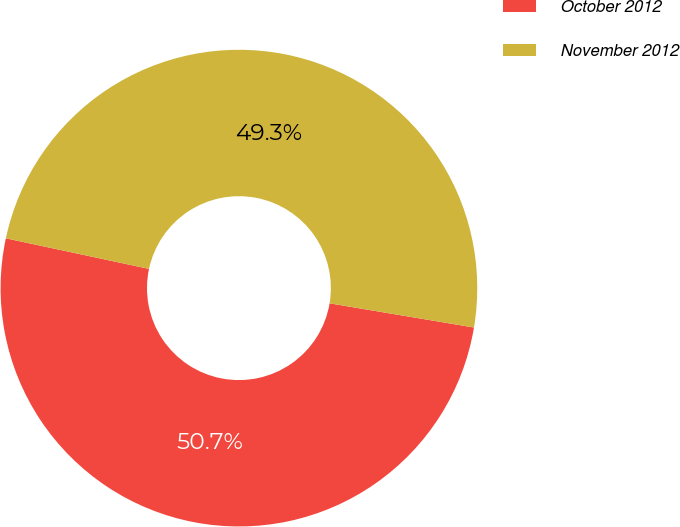Convert chart. <chart><loc_0><loc_0><loc_500><loc_500><pie_chart><fcel>October 2012<fcel>November 2012<nl><fcel>50.71%<fcel>49.29%<nl></chart> 